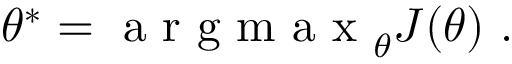<formula> <loc_0><loc_0><loc_500><loc_500>\theta ^ { * } = a r g m a x _ { \theta } J ( \theta ) .</formula> 